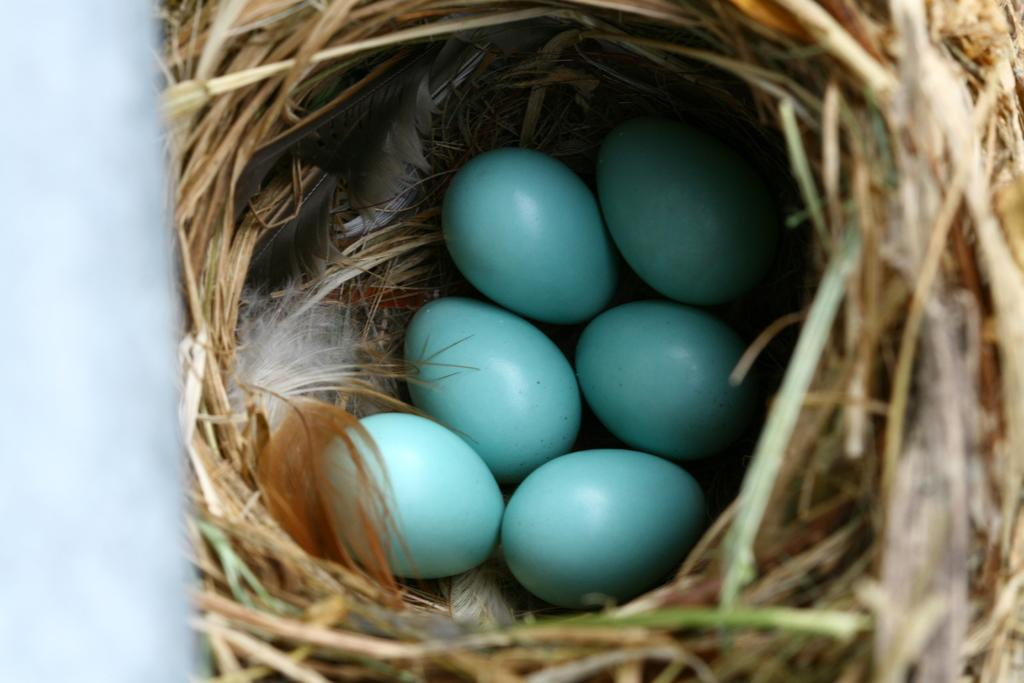What can be seen in the picture? There is a nest in the picture. How many eggs are in the nest? There are six eggs in the nest. What color are the eggs? The eggs are blue in color. What type of bag is hanging from the nest in the image? There is no bag present in the image; it only features a nest with blue eggs. What shape is the whip that is being used to crack the eggs in the image? There is no whip or cracking of eggs in the image; it only features a nest with blue eggs. 